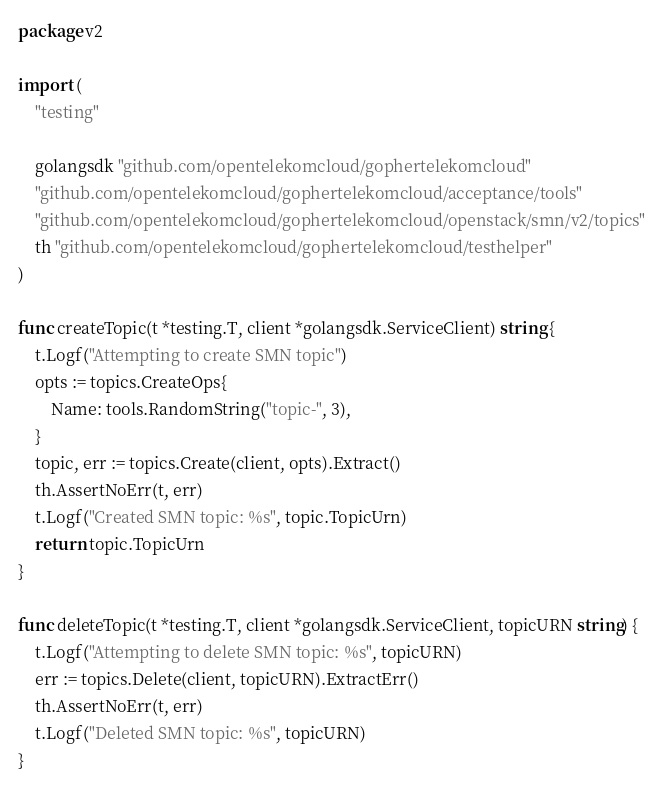Convert code to text. <code><loc_0><loc_0><loc_500><loc_500><_Go_>package v2

import (
	"testing"

	golangsdk "github.com/opentelekomcloud/gophertelekomcloud"
	"github.com/opentelekomcloud/gophertelekomcloud/acceptance/tools"
	"github.com/opentelekomcloud/gophertelekomcloud/openstack/smn/v2/topics"
	th "github.com/opentelekomcloud/gophertelekomcloud/testhelper"
)

func createTopic(t *testing.T, client *golangsdk.ServiceClient) string {
	t.Logf("Attempting to create SMN topic")
	opts := topics.CreateOps{
		Name: tools.RandomString("topic-", 3),
	}
	topic, err := topics.Create(client, opts).Extract()
	th.AssertNoErr(t, err)
	t.Logf("Created SMN topic: %s", topic.TopicUrn)
	return topic.TopicUrn
}

func deleteTopic(t *testing.T, client *golangsdk.ServiceClient, topicURN string) {
	t.Logf("Attempting to delete SMN topic: %s", topicURN)
	err := topics.Delete(client, topicURN).ExtractErr()
	th.AssertNoErr(t, err)
	t.Logf("Deleted SMN topic: %s", topicURN)
}
</code> 